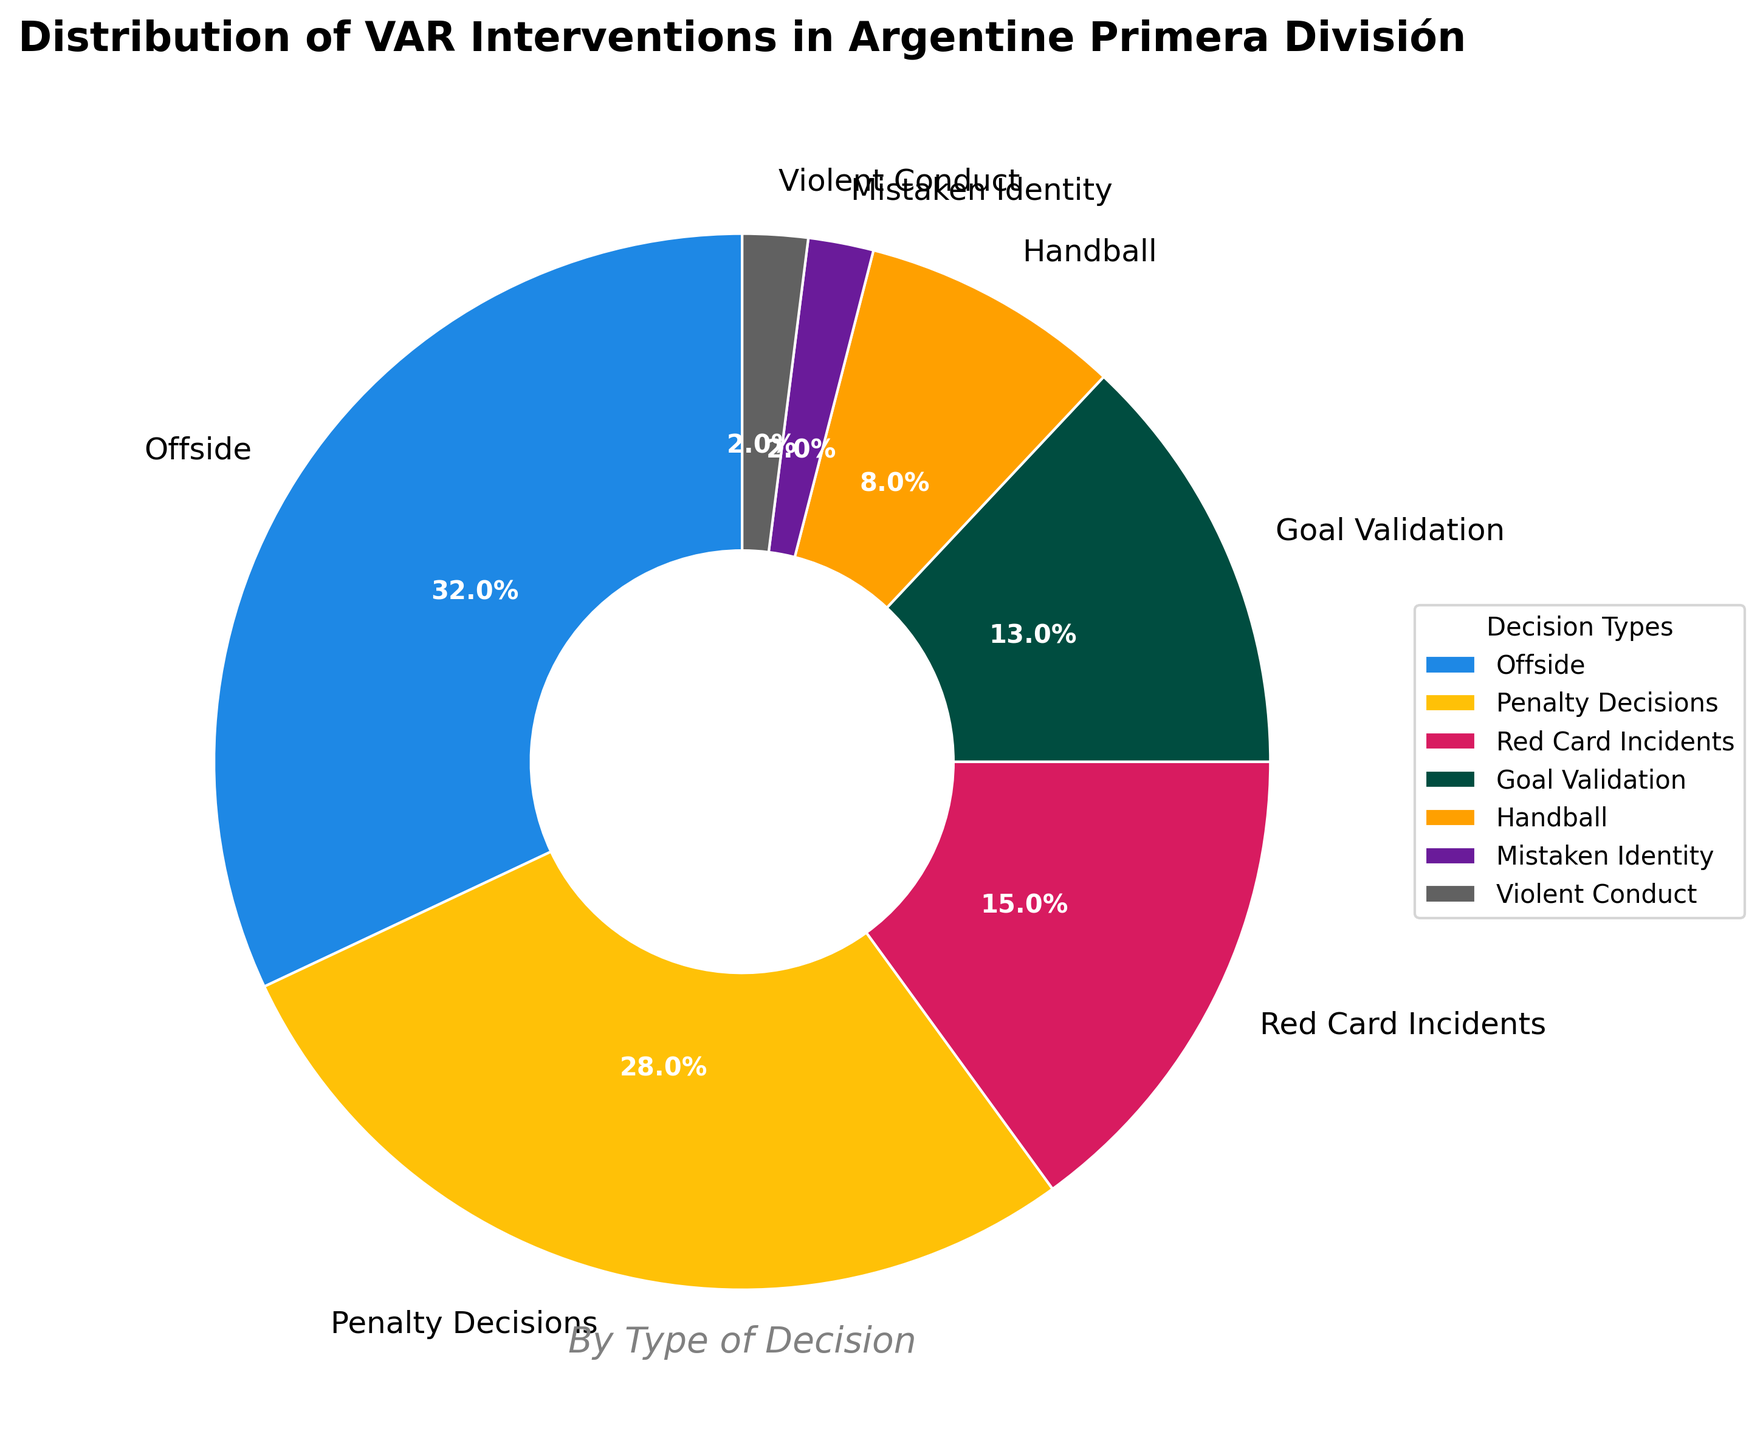Which decision type had the highest percentage of VAR interventions? Observe that 'Offside' has the largest portion in the chart labeled with 32% of the total.
Answer: Offside Which decision type had the lowest percentage of VAR interventions? Notice that 'Mistaken Identity' and 'Violent Conduct' both have the smallest slices, each labeled with 2%.
Answer: Mistaken Identity and Violent Conduct What is the combined percentage of VAR interventions for 'Penalty Decisions' and 'Red Card Incidents'? Add the percentages of 'Penalty Decisions' (28%) and 'Red Card Incidents' (15%). 28% + 15% = 43%
Answer: 43% How much more frequently did VAR intervene for 'Offside' compared to 'Handball'? Subtract the percentage of 'Handball' (8%) from the percentage of 'Offside' (32%). 32% - 8% = 24%
Answer: 24% more Which decision types have a percentage of VAR interventions greater than 20%? Identify the slices labeled with percentages greater than 20%, specifically 'Offside' (32%) and 'Penalty Decisions' (28%).
Answer: Offside and Penalty Decisions Are 'Goal Validation' interventions more or less frequent than 'Red Card Incidents'? Compare the percentages: 'Goal Validation' is 13% and 'Red Card Incidents' is 15%. 13% < 15%, hence 'Goal Validation' is less frequent.
Answer: Less frequent What percentage of VAR interventions is related to 'Handball' and 'Mistaken Identity' combined? Add the percentages of 'Handball' (8%) and 'Mistaken Identity' (2%). 8% + 2% = 10%
Answer: 10% Which decision type has an 8% intervention rate, and what is its color in the chart? Find the slice labeled with 8%, which corresponds to 'Handball'. The color of this slice in the chart is '#FFA000'.
Answer: Handball, orange What is the difference in percentage between 'Goal Validation' and 'Red Card Incidents'? Subtract the percentage of 'Goal Validation' (13%) from the percentage of 'Red Card Incidents' (15%). 15% - 13% = 2%
Answer: 2% What decision type accounts for nearly one-third of all VAR interventions? Notice that the slice labeled 'Offside' constitutes 32% of the interventions, which is approximately one-third of the total.
Answer: Offside 